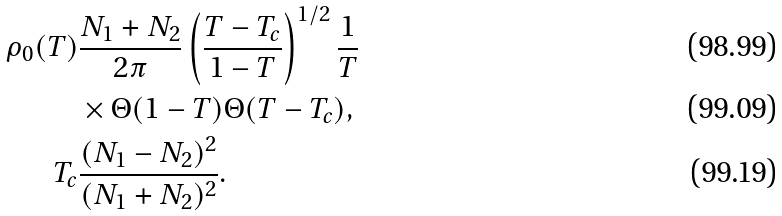<formula> <loc_0><loc_0><loc_500><loc_500>\rho _ { 0 } ( T ) & \frac { N _ { 1 } + N _ { 2 } } { 2 \pi } \left ( \frac { T - T _ { c } } { 1 - T } \right ) ^ { 1 / 2 } \frac { 1 } { T } \\ & \times \Theta ( 1 - T ) \Theta ( T - T _ { c } ) , \\ T _ { c } & \frac { ( N _ { 1 } - N _ { 2 } ) ^ { 2 } } { ( N _ { 1 } + N _ { 2 } ) ^ { 2 } } .</formula> 